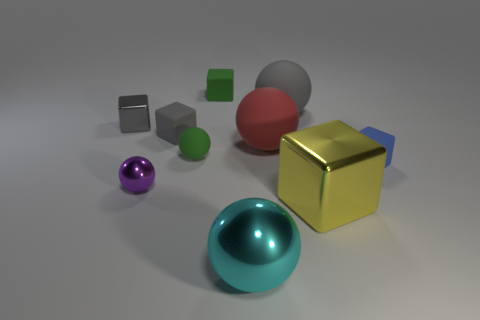Subtract 2 blocks. How many blocks are left? 3 Subtract all cyan balls. How many balls are left? 4 Subtract all small green rubber cubes. How many cubes are left? 4 Subtract all red cubes. Subtract all green spheres. How many cubes are left? 5 Add 4 purple things. How many purple things exist? 5 Subtract 0 blue cylinders. How many objects are left? 10 Subtract all small cylinders. Subtract all big gray spheres. How many objects are left? 9 Add 1 small blue cubes. How many small blue cubes are left? 2 